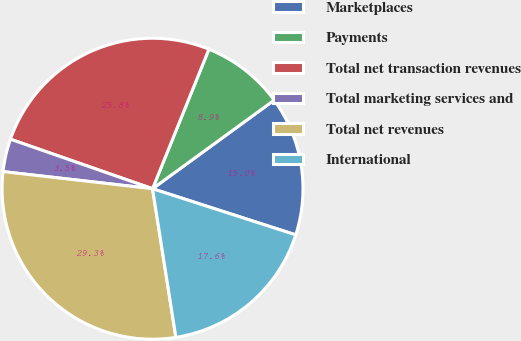Convert chart. <chart><loc_0><loc_0><loc_500><loc_500><pie_chart><fcel>Marketplaces<fcel>Payments<fcel>Total net transaction revenues<fcel>Total marketing services and<fcel>Total net revenues<fcel>International<nl><fcel>14.98%<fcel>8.87%<fcel>25.78%<fcel>3.52%<fcel>29.3%<fcel>17.56%<nl></chart> 